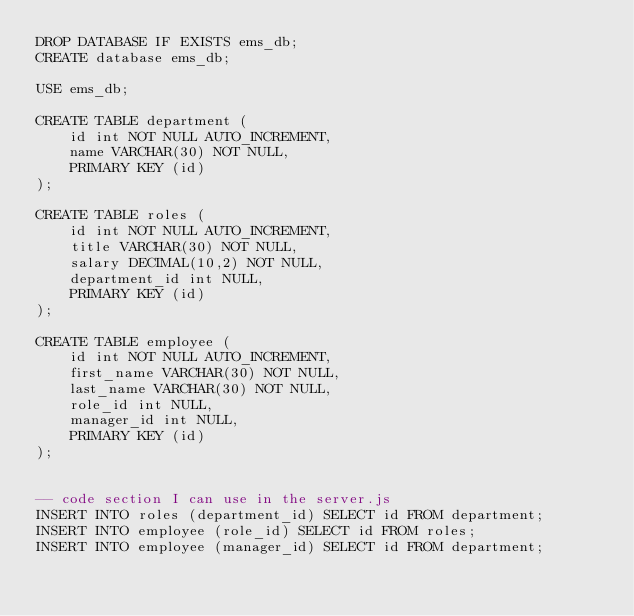Convert code to text. <code><loc_0><loc_0><loc_500><loc_500><_SQL_>DROP DATABASE IF EXISTS ems_db;
CREATE database ems_db;

USE ems_db;

CREATE TABLE department (
    id int NOT NULL AUTO_INCREMENT,
    name VARCHAR(30) NOT NULL,
    PRIMARY KEY (id)
);

CREATE TABLE roles (
    id int NOT NULL AUTO_INCREMENT,
    title VARCHAR(30) NOT NULL,
    salary DECIMAL(10,2) NOT NULL,
    department_id int NULL,
    PRIMARY KEY (id)
);

CREATE TABLE employee (
    id int NOT NULL AUTO_INCREMENT,
    first_name VARCHAR(30) NOT NULL,
    last_name VARCHAR(30) NOT NULL,
    role_id int NULL,
    manager_id int NULL,
    PRIMARY KEY (id)
);


-- code section I can use in the server.js 
INSERT INTO roles (department_id) SELECT id FROM department;
INSERT INTO employee (role_id) SELECT id FROM roles;
INSERT INTO employee (manager_id) SELECT id FROM department;
</code> 